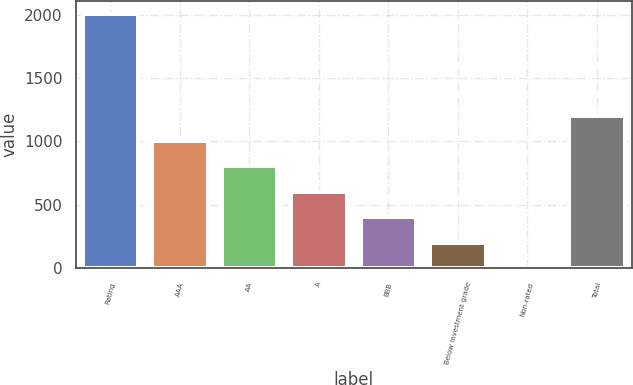Convert chart to OTSL. <chart><loc_0><loc_0><loc_500><loc_500><bar_chart><fcel>Rating<fcel>AAA<fcel>AA<fcel>A<fcel>BBB<fcel>Below investment grade<fcel>Non-rated<fcel>Total<nl><fcel>2006<fcel>1003.5<fcel>803<fcel>602.5<fcel>402<fcel>201.5<fcel>1<fcel>1204<nl></chart> 